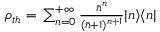<formula> <loc_0><loc_0><loc_500><loc_500>\begin{array} { r } { \rho _ { t h } = \, \sum _ { n = 0 } ^ { + \infty } \frac { \bar { n } ^ { n } } { ( \bar { n } + 1 ) ^ { n + 1 } } | n \rangle \langle n | } \end{array}</formula> 